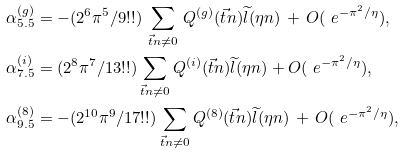Convert formula to latex. <formula><loc_0><loc_0><loc_500><loc_500>\alpha ^ { ( g ) } _ { 5 . 5 } & = - ( 2 ^ { 6 } \pi ^ { 5 } / 9 ! ! ) \, \sum _ { \vec { t } n \ne 0 } \, Q ^ { ( g ) } ( \vec { t } n ) \widetilde { l } ( \eta n ) \, + \, O ( \ e ^ { - \pi ^ { 2 } / \eta } ) , \\ \alpha ^ { ( i ) } _ { 7 . 5 } & = ( 2 ^ { 8 } \pi ^ { 7 } / 1 3 ! ! ) \sum _ { \vec { t } n \ne 0 } Q ^ { ( i ) } ( \vec { t } n ) \widetilde { l } ( \eta n ) + O ( \ e ^ { - \pi ^ { 2 } / \eta } ) , \\ \alpha ^ { ( 8 ) } _ { 9 . 5 } & = - ( 2 ^ { 1 0 } \pi ^ { 9 } / 1 7 ! ! ) \sum _ { \vec { t } n \ne 0 } Q ^ { ( 8 ) } ( \vec { t } n ) \widetilde { l } ( \eta n ) \, + \, O ( \ e ^ { - \pi ^ { 2 } / \eta } ) ,</formula> 